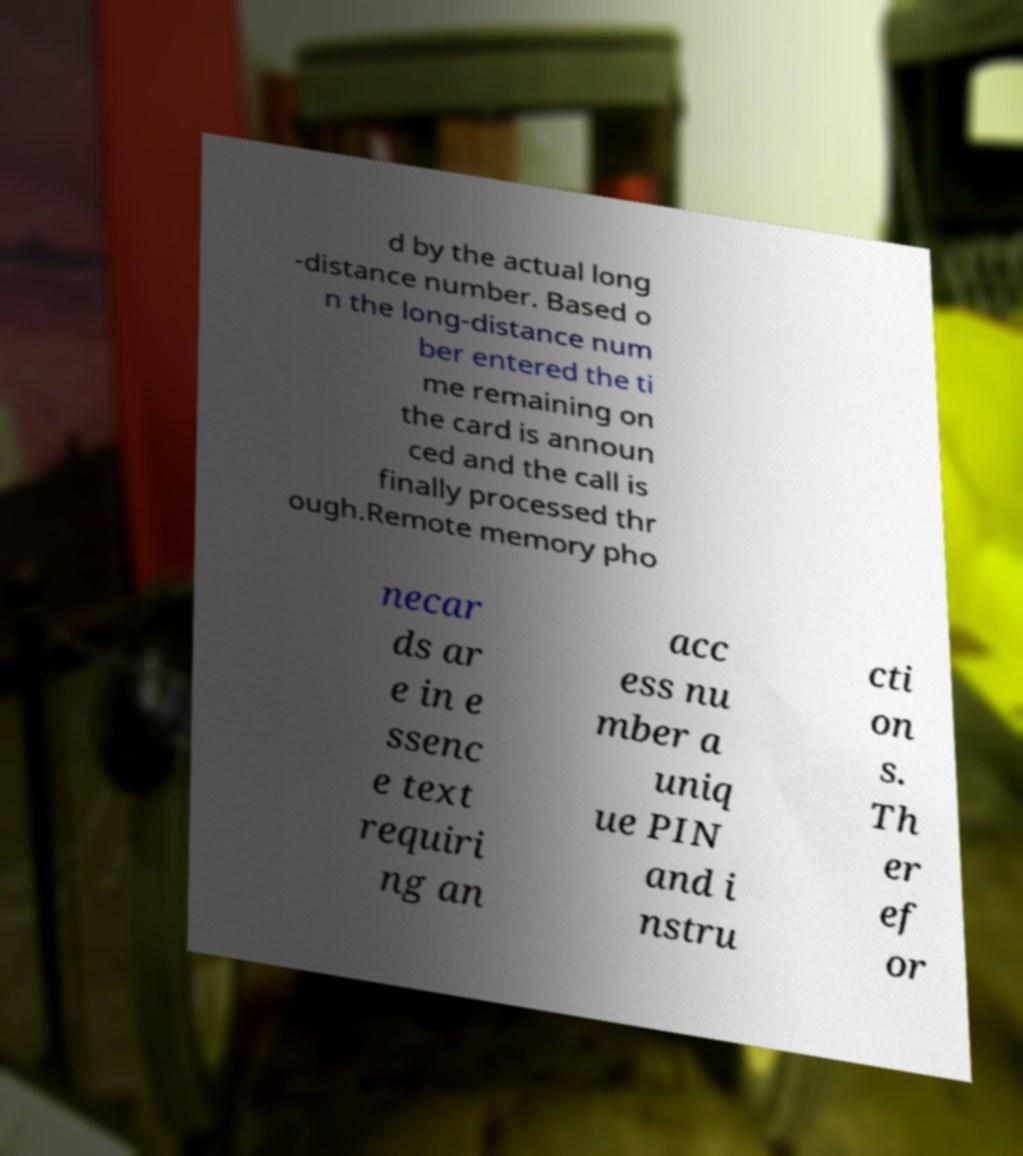I need the written content from this picture converted into text. Can you do that? d by the actual long -distance number. Based o n the long-distance num ber entered the ti me remaining on the card is announ ced and the call is finally processed thr ough.Remote memory pho necar ds ar e in e ssenc e text requiri ng an acc ess nu mber a uniq ue PIN and i nstru cti on s. Th er ef or 